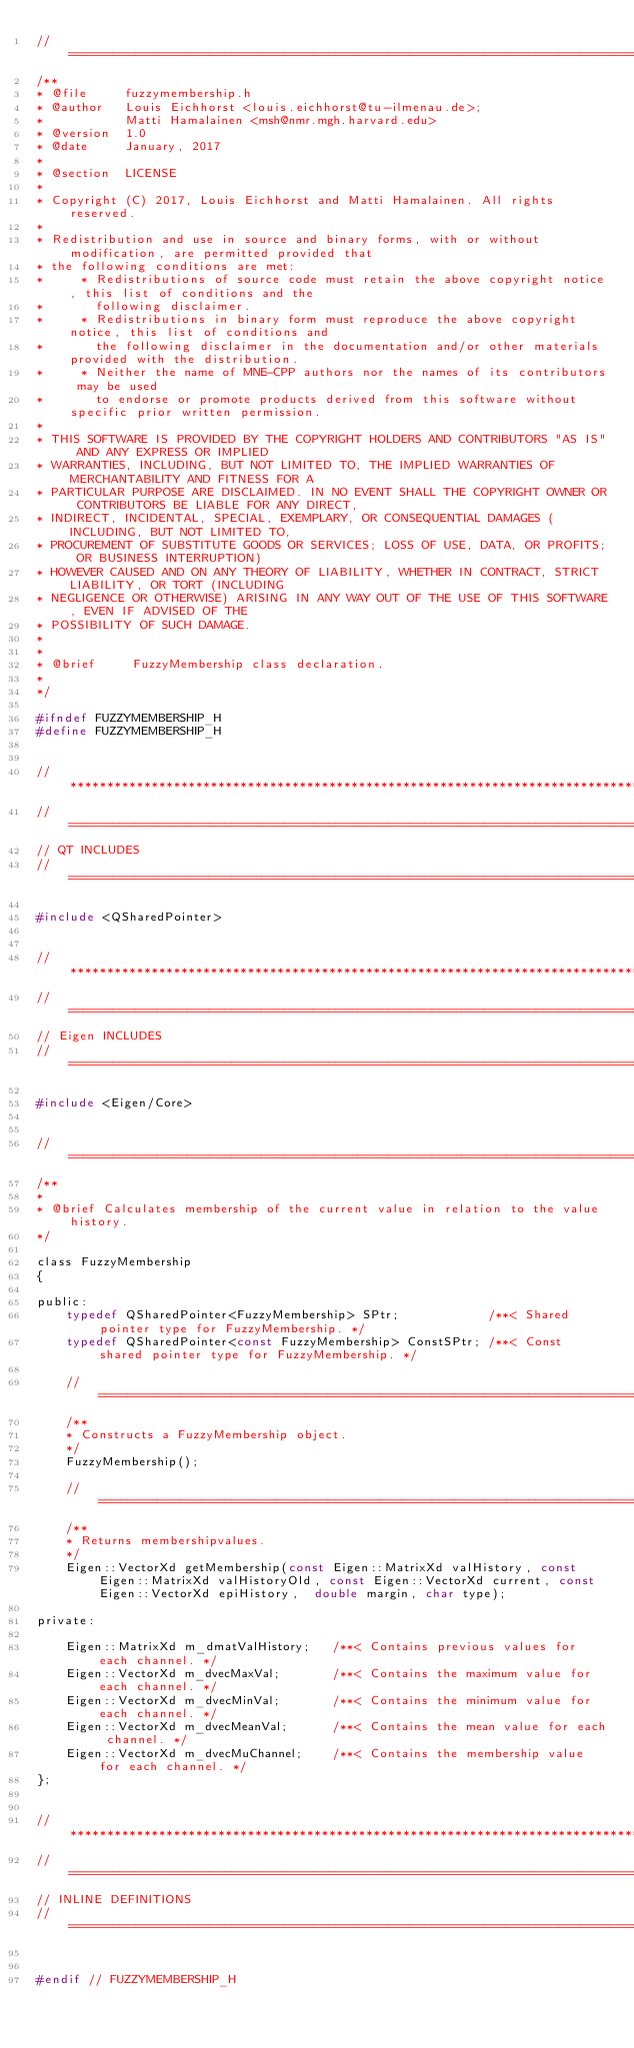<code> <loc_0><loc_0><loc_500><loc_500><_C_>//=============================================================================================================
/**
* @file     fuzzymembership.h
* @author   Louis Eichhorst <louis.eichhorst@tu-ilmenau.de>;
*           Matti Hamalainen <msh@nmr.mgh.harvard.edu>
* @version  1.0
* @date     January, 2017
*
* @section  LICENSE
*
* Copyright (C) 2017, Louis Eichhorst and Matti Hamalainen. All rights reserved.
*
* Redistribution and use in source and binary forms, with or without modification, are permitted provided that
* the following conditions are met:
*     * Redistributions of source code must retain the above copyright notice, this list of conditions and the
*       following disclaimer.
*     * Redistributions in binary form must reproduce the above copyright notice, this list of conditions and
*       the following disclaimer in the documentation and/or other materials provided with the distribution.
*     * Neither the name of MNE-CPP authors nor the names of its contributors may be used
*       to endorse or promote products derived from this software without specific prior written permission.
*
* THIS SOFTWARE IS PROVIDED BY THE COPYRIGHT HOLDERS AND CONTRIBUTORS "AS IS" AND ANY EXPRESS OR IMPLIED
* WARRANTIES, INCLUDING, BUT NOT LIMITED TO, THE IMPLIED WARRANTIES OF MERCHANTABILITY AND FITNESS FOR A
* PARTICULAR PURPOSE ARE DISCLAIMED. IN NO EVENT SHALL THE COPYRIGHT OWNER OR CONTRIBUTORS BE LIABLE FOR ANY DIRECT,
* INDIRECT, INCIDENTAL, SPECIAL, EXEMPLARY, OR CONSEQUENTIAL DAMAGES (INCLUDING, BUT NOT LIMITED TO,
* PROCUREMENT OF SUBSTITUTE GOODS OR SERVICES; LOSS OF USE, DATA, OR PROFITS; OR BUSINESS INTERRUPTION)
* HOWEVER CAUSED AND ON ANY THEORY OF LIABILITY, WHETHER IN CONTRACT, STRICT LIABILITY, OR TORT (INCLUDING
* NEGLIGENCE OR OTHERWISE) ARISING IN ANY WAY OUT OF THE USE OF THIS SOFTWARE, EVEN IF ADVISED OF THE
* POSSIBILITY OF SUCH DAMAGE.
*
*
* @brief     FuzzyMembership class declaration.
*
*/

#ifndef FUZZYMEMBERSHIP_H
#define FUZZYMEMBERSHIP_H


//*************************************************************************************************************
//=============================================================================================================
// QT INCLUDES
//=============================================================================================================

#include <QSharedPointer>


//*************************************************************************************************************
//=============================================================================================================
// Eigen INCLUDES
//=============================================================================================================

#include <Eigen/Core>


//=============================================================================================================
/**
*
* @brief Calculates membership of the current value in relation to the value history.
*/

class FuzzyMembership
{

public:
    typedef QSharedPointer<FuzzyMembership> SPtr;            /**< Shared pointer type for FuzzyMembership. */
    typedef QSharedPointer<const FuzzyMembership> ConstSPtr; /**< Const shared pointer type for FuzzyMembership. */

    //=========================================================================================================
    /**
    * Constructs a FuzzyMembership object.
    */
    FuzzyMembership();

    //=========================================================================================================
    /**
    * Returns membershipvalues.
    */
    Eigen::VectorXd getMembership(const Eigen::MatrixXd valHistory, const Eigen::MatrixXd valHistoryOld, const Eigen::VectorXd current, const Eigen::VectorXd epiHistory,  double margin, char type);

private:

    Eigen::MatrixXd m_dmatValHistory;   /**< Contains previous values for each channel. */
    Eigen::VectorXd m_dvecMaxVal;       /**< Contains the maximum value for each channel. */
    Eigen::VectorXd m_dvecMinVal;       /**< Contains the minimum value for each channel. */
    Eigen::VectorXd m_dvecMeanVal;      /**< Contains the mean value for each channel. */
    Eigen::VectorXd m_dvecMuChannel;    /**< Contains the membership value for each channel. */
};


//*************************************************************************************************************
//=============================================================================================================
// INLINE DEFINITIONS
//=============================================================================================================


#endif // FUZZYMEMBERSHIP_H
</code> 